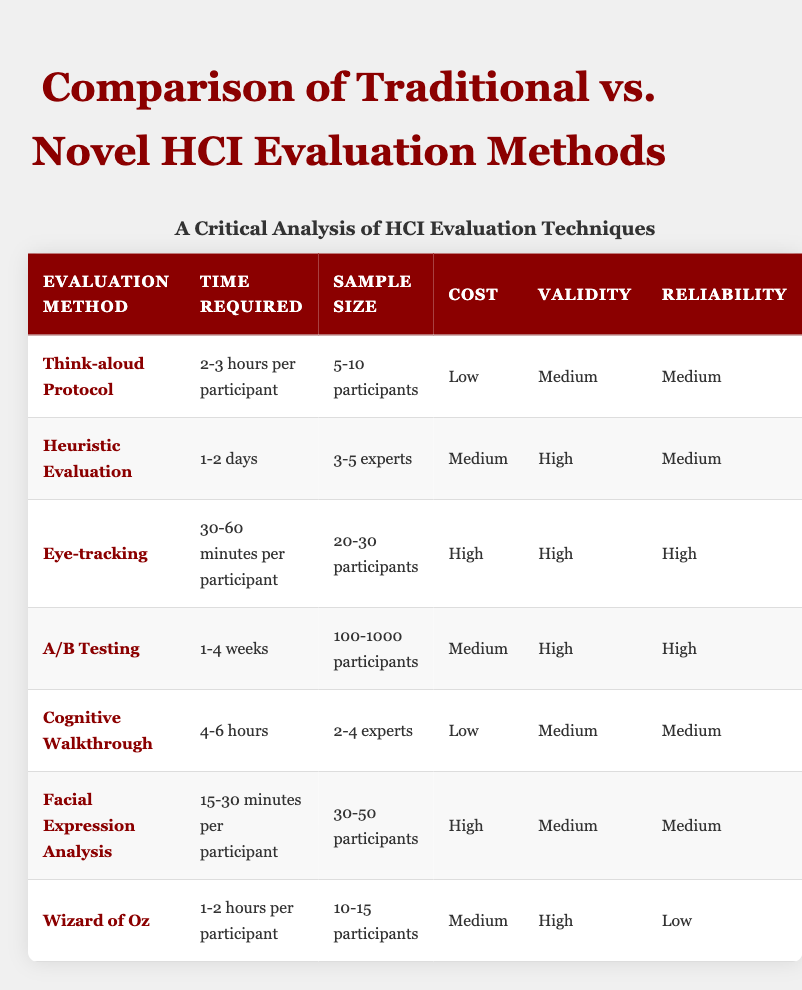What is the time required for Eye-tracking? The table indicates that Eye-tracking requires "30-60 minutes per participant."
Answer: 30-60 minutes per participant Which evaluation method has the highest validity? By examining the 'Validity' column, both Eye-tracking and A/B Testing are listed as "High" in validity.
Answer: Eye-tracking and A/B Testing What is the cost of Cognitive Walkthrough? The table indicates that the cost for Cognitive Walkthrough is "Low."
Answer: Low How many participants are required for A/B Testing? Referring to the 'Sample Size' column for A/B Testing, it states "100-1000 participants."
Answer: 100-1000 participants Which evaluation method has the lowest reliability? Checking the 'Reliability' column, we see that Wizard of Oz has "Low" reliability, which is the lowest compared to other methods.
Answer: Wizard of Oz What is the average time required for Facial Expression Analysis and Eye-tracking? The time for Facial Expression Analysis is 15-30 minutes per participant, and for Eye-tracking, it's 30-60 minutes. Taking the average, we consider the midpoints: 22.5 minutes for Facial Expression Analysis and 45 minutes for Eye-tracking. Thus, the average time is (22.5 + 45) / 2 = 33.75 minutes.
Answer: 33.75 minutes Is the sample size for Heuristic Evaluation greater than that for Cognitive Walkthrough? Heuristic Evaluation requires "3-5 experts," while Cognitive Walkthrough requires "2-4 experts." Since "3-5" is greater than "2-4," the sample size for Heuristic Evaluation is indeed greater.
Answer: Yes Which methods are considered high in both validity and reliability? Looking in both the 'Validity' and 'Reliability' columns, Eye-tracking and A/B Testing are the only methods designated as "High" in both categories.
Answer: Eye-tracking and A/B Testing What is the difference in time required between Think-aloud Protocol and Wizard of Oz? Think-aloud Protocol requires "2-3 hours per participant," while Wizard of Oz requires "1-2 hours per participant." Calculating the maximum difference: 3 hours (180 minutes) - 2 hours (120 minutes) = 60 minutes as the maximum difference, and the minimum difference is 2 hours (120 minutes) - 1 hour (60 minutes) = 60 minutes as well. The difference in time required is consistently 60 minutes.
Answer: 60 minutes 